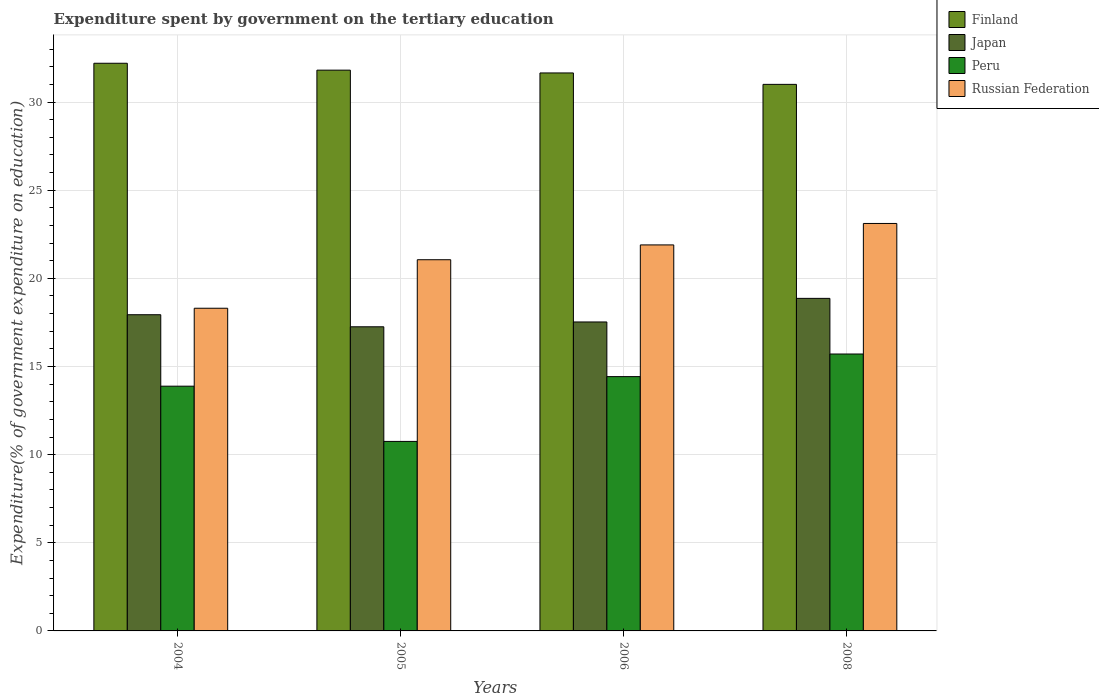Are the number of bars per tick equal to the number of legend labels?
Your answer should be compact. Yes. How many bars are there on the 3rd tick from the left?
Give a very brief answer. 4. What is the label of the 2nd group of bars from the left?
Your answer should be compact. 2005. In how many cases, is the number of bars for a given year not equal to the number of legend labels?
Your response must be concise. 0. What is the expenditure spent by government on the tertiary education in Peru in 2008?
Your answer should be very brief. 15.71. Across all years, what is the maximum expenditure spent by government on the tertiary education in Japan?
Keep it short and to the point. 18.86. Across all years, what is the minimum expenditure spent by government on the tertiary education in Russian Federation?
Your response must be concise. 18.3. In which year was the expenditure spent by government on the tertiary education in Peru maximum?
Keep it short and to the point. 2008. In which year was the expenditure spent by government on the tertiary education in Finland minimum?
Your answer should be compact. 2008. What is the total expenditure spent by government on the tertiary education in Peru in the graph?
Keep it short and to the point. 54.77. What is the difference between the expenditure spent by government on the tertiary education in Finland in 2004 and that in 2008?
Offer a terse response. 1.2. What is the difference between the expenditure spent by government on the tertiary education in Russian Federation in 2008 and the expenditure spent by government on the tertiary education in Peru in 2005?
Ensure brevity in your answer.  12.36. What is the average expenditure spent by government on the tertiary education in Russian Federation per year?
Give a very brief answer. 21.09. In the year 2004, what is the difference between the expenditure spent by government on the tertiary education in Peru and expenditure spent by government on the tertiary education in Japan?
Offer a terse response. -4.05. In how many years, is the expenditure spent by government on the tertiary education in Peru greater than 17 %?
Provide a succinct answer. 0. What is the ratio of the expenditure spent by government on the tertiary education in Finland in 2004 to that in 2005?
Make the answer very short. 1.01. Is the expenditure spent by government on the tertiary education in Russian Federation in 2005 less than that in 2006?
Offer a terse response. Yes. What is the difference between the highest and the second highest expenditure spent by government on the tertiary education in Finland?
Ensure brevity in your answer.  0.39. What is the difference between the highest and the lowest expenditure spent by government on the tertiary education in Russian Federation?
Provide a succinct answer. 4.81. In how many years, is the expenditure spent by government on the tertiary education in Japan greater than the average expenditure spent by government on the tertiary education in Japan taken over all years?
Provide a short and direct response. 2. Is the sum of the expenditure spent by government on the tertiary education in Japan in 2005 and 2008 greater than the maximum expenditure spent by government on the tertiary education in Peru across all years?
Offer a terse response. Yes. What does the 2nd bar from the left in 2005 represents?
Your answer should be compact. Japan. What does the 3rd bar from the right in 2008 represents?
Provide a succinct answer. Japan. How many years are there in the graph?
Your answer should be compact. 4. Does the graph contain any zero values?
Make the answer very short. No. Does the graph contain grids?
Provide a short and direct response. Yes. Where does the legend appear in the graph?
Your answer should be compact. Top right. What is the title of the graph?
Your answer should be compact. Expenditure spent by government on the tertiary education. Does "Bolivia" appear as one of the legend labels in the graph?
Ensure brevity in your answer.  No. What is the label or title of the Y-axis?
Your answer should be compact. Expenditure(% of government expenditure on education). What is the Expenditure(% of government expenditure on education) in Finland in 2004?
Make the answer very short. 32.2. What is the Expenditure(% of government expenditure on education) in Japan in 2004?
Your response must be concise. 17.94. What is the Expenditure(% of government expenditure on education) in Peru in 2004?
Provide a short and direct response. 13.88. What is the Expenditure(% of government expenditure on education) of Russian Federation in 2004?
Keep it short and to the point. 18.3. What is the Expenditure(% of government expenditure on education) in Finland in 2005?
Provide a succinct answer. 31.81. What is the Expenditure(% of government expenditure on education) of Japan in 2005?
Offer a terse response. 17.25. What is the Expenditure(% of government expenditure on education) of Peru in 2005?
Your response must be concise. 10.75. What is the Expenditure(% of government expenditure on education) of Russian Federation in 2005?
Ensure brevity in your answer.  21.06. What is the Expenditure(% of government expenditure on education) in Finland in 2006?
Your response must be concise. 31.65. What is the Expenditure(% of government expenditure on education) of Japan in 2006?
Give a very brief answer. 17.53. What is the Expenditure(% of government expenditure on education) of Peru in 2006?
Keep it short and to the point. 14.43. What is the Expenditure(% of government expenditure on education) in Russian Federation in 2006?
Ensure brevity in your answer.  21.9. What is the Expenditure(% of government expenditure on education) in Finland in 2008?
Offer a very short reply. 31. What is the Expenditure(% of government expenditure on education) in Japan in 2008?
Make the answer very short. 18.86. What is the Expenditure(% of government expenditure on education) in Peru in 2008?
Keep it short and to the point. 15.71. What is the Expenditure(% of government expenditure on education) in Russian Federation in 2008?
Offer a terse response. 23.11. Across all years, what is the maximum Expenditure(% of government expenditure on education) of Finland?
Offer a very short reply. 32.2. Across all years, what is the maximum Expenditure(% of government expenditure on education) of Japan?
Ensure brevity in your answer.  18.86. Across all years, what is the maximum Expenditure(% of government expenditure on education) in Peru?
Ensure brevity in your answer.  15.71. Across all years, what is the maximum Expenditure(% of government expenditure on education) of Russian Federation?
Provide a succinct answer. 23.11. Across all years, what is the minimum Expenditure(% of government expenditure on education) of Finland?
Offer a very short reply. 31. Across all years, what is the minimum Expenditure(% of government expenditure on education) of Japan?
Provide a short and direct response. 17.25. Across all years, what is the minimum Expenditure(% of government expenditure on education) in Peru?
Offer a very short reply. 10.75. Across all years, what is the minimum Expenditure(% of government expenditure on education) of Russian Federation?
Your response must be concise. 18.3. What is the total Expenditure(% of government expenditure on education) of Finland in the graph?
Your response must be concise. 126.67. What is the total Expenditure(% of government expenditure on education) of Japan in the graph?
Your response must be concise. 71.58. What is the total Expenditure(% of government expenditure on education) of Peru in the graph?
Your answer should be compact. 54.77. What is the total Expenditure(% of government expenditure on education) of Russian Federation in the graph?
Your answer should be compact. 84.37. What is the difference between the Expenditure(% of government expenditure on education) in Finland in 2004 and that in 2005?
Make the answer very short. 0.39. What is the difference between the Expenditure(% of government expenditure on education) in Japan in 2004 and that in 2005?
Offer a very short reply. 0.68. What is the difference between the Expenditure(% of government expenditure on education) in Peru in 2004 and that in 2005?
Give a very brief answer. 3.13. What is the difference between the Expenditure(% of government expenditure on education) in Russian Federation in 2004 and that in 2005?
Your answer should be compact. -2.75. What is the difference between the Expenditure(% of government expenditure on education) in Finland in 2004 and that in 2006?
Your answer should be very brief. 0.55. What is the difference between the Expenditure(% of government expenditure on education) in Japan in 2004 and that in 2006?
Your answer should be very brief. 0.41. What is the difference between the Expenditure(% of government expenditure on education) in Peru in 2004 and that in 2006?
Your response must be concise. -0.54. What is the difference between the Expenditure(% of government expenditure on education) in Russian Federation in 2004 and that in 2006?
Make the answer very short. -3.59. What is the difference between the Expenditure(% of government expenditure on education) in Finland in 2004 and that in 2008?
Your answer should be very brief. 1.2. What is the difference between the Expenditure(% of government expenditure on education) of Japan in 2004 and that in 2008?
Ensure brevity in your answer.  -0.93. What is the difference between the Expenditure(% of government expenditure on education) in Peru in 2004 and that in 2008?
Offer a very short reply. -1.82. What is the difference between the Expenditure(% of government expenditure on education) in Russian Federation in 2004 and that in 2008?
Ensure brevity in your answer.  -4.81. What is the difference between the Expenditure(% of government expenditure on education) of Finland in 2005 and that in 2006?
Your answer should be compact. 0.16. What is the difference between the Expenditure(% of government expenditure on education) of Japan in 2005 and that in 2006?
Ensure brevity in your answer.  -0.27. What is the difference between the Expenditure(% of government expenditure on education) of Peru in 2005 and that in 2006?
Provide a short and direct response. -3.68. What is the difference between the Expenditure(% of government expenditure on education) in Russian Federation in 2005 and that in 2006?
Make the answer very short. -0.84. What is the difference between the Expenditure(% of government expenditure on education) of Finland in 2005 and that in 2008?
Provide a short and direct response. 0.81. What is the difference between the Expenditure(% of government expenditure on education) of Japan in 2005 and that in 2008?
Offer a very short reply. -1.61. What is the difference between the Expenditure(% of government expenditure on education) in Peru in 2005 and that in 2008?
Ensure brevity in your answer.  -4.96. What is the difference between the Expenditure(% of government expenditure on education) in Russian Federation in 2005 and that in 2008?
Your answer should be very brief. -2.06. What is the difference between the Expenditure(% of government expenditure on education) in Finland in 2006 and that in 2008?
Give a very brief answer. 0.65. What is the difference between the Expenditure(% of government expenditure on education) of Japan in 2006 and that in 2008?
Provide a succinct answer. -1.34. What is the difference between the Expenditure(% of government expenditure on education) in Peru in 2006 and that in 2008?
Keep it short and to the point. -1.28. What is the difference between the Expenditure(% of government expenditure on education) in Russian Federation in 2006 and that in 2008?
Ensure brevity in your answer.  -1.22. What is the difference between the Expenditure(% of government expenditure on education) of Finland in 2004 and the Expenditure(% of government expenditure on education) of Japan in 2005?
Ensure brevity in your answer.  14.95. What is the difference between the Expenditure(% of government expenditure on education) in Finland in 2004 and the Expenditure(% of government expenditure on education) in Peru in 2005?
Provide a short and direct response. 21.45. What is the difference between the Expenditure(% of government expenditure on education) of Finland in 2004 and the Expenditure(% of government expenditure on education) of Russian Federation in 2005?
Your response must be concise. 11.14. What is the difference between the Expenditure(% of government expenditure on education) of Japan in 2004 and the Expenditure(% of government expenditure on education) of Peru in 2005?
Make the answer very short. 7.19. What is the difference between the Expenditure(% of government expenditure on education) in Japan in 2004 and the Expenditure(% of government expenditure on education) in Russian Federation in 2005?
Provide a short and direct response. -3.12. What is the difference between the Expenditure(% of government expenditure on education) in Peru in 2004 and the Expenditure(% of government expenditure on education) in Russian Federation in 2005?
Your answer should be very brief. -7.17. What is the difference between the Expenditure(% of government expenditure on education) of Finland in 2004 and the Expenditure(% of government expenditure on education) of Japan in 2006?
Ensure brevity in your answer.  14.68. What is the difference between the Expenditure(% of government expenditure on education) of Finland in 2004 and the Expenditure(% of government expenditure on education) of Peru in 2006?
Offer a very short reply. 17.78. What is the difference between the Expenditure(% of government expenditure on education) in Finland in 2004 and the Expenditure(% of government expenditure on education) in Russian Federation in 2006?
Your response must be concise. 10.3. What is the difference between the Expenditure(% of government expenditure on education) of Japan in 2004 and the Expenditure(% of government expenditure on education) of Peru in 2006?
Provide a succinct answer. 3.51. What is the difference between the Expenditure(% of government expenditure on education) of Japan in 2004 and the Expenditure(% of government expenditure on education) of Russian Federation in 2006?
Your answer should be very brief. -3.96. What is the difference between the Expenditure(% of government expenditure on education) of Peru in 2004 and the Expenditure(% of government expenditure on education) of Russian Federation in 2006?
Your response must be concise. -8.01. What is the difference between the Expenditure(% of government expenditure on education) of Finland in 2004 and the Expenditure(% of government expenditure on education) of Japan in 2008?
Provide a succinct answer. 13.34. What is the difference between the Expenditure(% of government expenditure on education) of Finland in 2004 and the Expenditure(% of government expenditure on education) of Peru in 2008?
Your answer should be very brief. 16.49. What is the difference between the Expenditure(% of government expenditure on education) of Finland in 2004 and the Expenditure(% of government expenditure on education) of Russian Federation in 2008?
Keep it short and to the point. 9.09. What is the difference between the Expenditure(% of government expenditure on education) in Japan in 2004 and the Expenditure(% of government expenditure on education) in Peru in 2008?
Provide a short and direct response. 2.23. What is the difference between the Expenditure(% of government expenditure on education) in Japan in 2004 and the Expenditure(% of government expenditure on education) in Russian Federation in 2008?
Your answer should be very brief. -5.18. What is the difference between the Expenditure(% of government expenditure on education) of Peru in 2004 and the Expenditure(% of government expenditure on education) of Russian Federation in 2008?
Give a very brief answer. -9.23. What is the difference between the Expenditure(% of government expenditure on education) in Finland in 2005 and the Expenditure(% of government expenditure on education) in Japan in 2006?
Offer a very short reply. 14.28. What is the difference between the Expenditure(% of government expenditure on education) in Finland in 2005 and the Expenditure(% of government expenditure on education) in Peru in 2006?
Your response must be concise. 17.38. What is the difference between the Expenditure(% of government expenditure on education) of Finland in 2005 and the Expenditure(% of government expenditure on education) of Russian Federation in 2006?
Keep it short and to the point. 9.91. What is the difference between the Expenditure(% of government expenditure on education) of Japan in 2005 and the Expenditure(% of government expenditure on education) of Peru in 2006?
Provide a succinct answer. 2.83. What is the difference between the Expenditure(% of government expenditure on education) of Japan in 2005 and the Expenditure(% of government expenditure on education) of Russian Federation in 2006?
Provide a succinct answer. -4.64. What is the difference between the Expenditure(% of government expenditure on education) in Peru in 2005 and the Expenditure(% of government expenditure on education) in Russian Federation in 2006?
Your answer should be very brief. -11.15. What is the difference between the Expenditure(% of government expenditure on education) of Finland in 2005 and the Expenditure(% of government expenditure on education) of Japan in 2008?
Keep it short and to the point. 12.95. What is the difference between the Expenditure(% of government expenditure on education) of Finland in 2005 and the Expenditure(% of government expenditure on education) of Peru in 2008?
Provide a short and direct response. 16.1. What is the difference between the Expenditure(% of government expenditure on education) of Finland in 2005 and the Expenditure(% of government expenditure on education) of Russian Federation in 2008?
Offer a terse response. 8.7. What is the difference between the Expenditure(% of government expenditure on education) of Japan in 2005 and the Expenditure(% of government expenditure on education) of Peru in 2008?
Keep it short and to the point. 1.54. What is the difference between the Expenditure(% of government expenditure on education) in Japan in 2005 and the Expenditure(% of government expenditure on education) in Russian Federation in 2008?
Your response must be concise. -5.86. What is the difference between the Expenditure(% of government expenditure on education) of Peru in 2005 and the Expenditure(% of government expenditure on education) of Russian Federation in 2008?
Provide a short and direct response. -12.36. What is the difference between the Expenditure(% of government expenditure on education) in Finland in 2006 and the Expenditure(% of government expenditure on education) in Japan in 2008?
Provide a short and direct response. 12.79. What is the difference between the Expenditure(% of government expenditure on education) in Finland in 2006 and the Expenditure(% of government expenditure on education) in Peru in 2008?
Your answer should be very brief. 15.94. What is the difference between the Expenditure(% of government expenditure on education) of Finland in 2006 and the Expenditure(% of government expenditure on education) of Russian Federation in 2008?
Keep it short and to the point. 8.54. What is the difference between the Expenditure(% of government expenditure on education) in Japan in 2006 and the Expenditure(% of government expenditure on education) in Peru in 2008?
Offer a very short reply. 1.82. What is the difference between the Expenditure(% of government expenditure on education) in Japan in 2006 and the Expenditure(% of government expenditure on education) in Russian Federation in 2008?
Your answer should be compact. -5.59. What is the difference between the Expenditure(% of government expenditure on education) of Peru in 2006 and the Expenditure(% of government expenditure on education) of Russian Federation in 2008?
Offer a terse response. -8.69. What is the average Expenditure(% of government expenditure on education) of Finland per year?
Provide a short and direct response. 31.67. What is the average Expenditure(% of government expenditure on education) of Japan per year?
Keep it short and to the point. 17.89. What is the average Expenditure(% of government expenditure on education) of Peru per year?
Provide a succinct answer. 13.69. What is the average Expenditure(% of government expenditure on education) in Russian Federation per year?
Provide a succinct answer. 21.09. In the year 2004, what is the difference between the Expenditure(% of government expenditure on education) in Finland and Expenditure(% of government expenditure on education) in Japan?
Your response must be concise. 14.26. In the year 2004, what is the difference between the Expenditure(% of government expenditure on education) in Finland and Expenditure(% of government expenditure on education) in Peru?
Ensure brevity in your answer.  18.32. In the year 2004, what is the difference between the Expenditure(% of government expenditure on education) of Finland and Expenditure(% of government expenditure on education) of Russian Federation?
Your answer should be very brief. 13.9. In the year 2004, what is the difference between the Expenditure(% of government expenditure on education) of Japan and Expenditure(% of government expenditure on education) of Peru?
Ensure brevity in your answer.  4.05. In the year 2004, what is the difference between the Expenditure(% of government expenditure on education) of Japan and Expenditure(% of government expenditure on education) of Russian Federation?
Ensure brevity in your answer.  -0.37. In the year 2004, what is the difference between the Expenditure(% of government expenditure on education) in Peru and Expenditure(% of government expenditure on education) in Russian Federation?
Your answer should be compact. -4.42. In the year 2005, what is the difference between the Expenditure(% of government expenditure on education) of Finland and Expenditure(% of government expenditure on education) of Japan?
Your response must be concise. 14.56. In the year 2005, what is the difference between the Expenditure(% of government expenditure on education) of Finland and Expenditure(% of government expenditure on education) of Peru?
Offer a terse response. 21.06. In the year 2005, what is the difference between the Expenditure(% of government expenditure on education) of Finland and Expenditure(% of government expenditure on education) of Russian Federation?
Give a very brief answer. 10.75. In the year 2005, what is the difference between the Expenditure(% of government expenditure on education) of Japan and Expenditure(% of government expenditure on education) of Peru?
Provide a succinct answer. 6.5. In the year 2005, what is the difference between the Expenditure(% of government expenditure on education) of Japan and Expenditure(% of government expenditure on education) of Russian Federation?
Your response must be concise. -3.8. In the year 2005, what is the difference between the Expenditure(% of government expenditure on education) in Peru and Expenditure(% of government expenditure on education) in Russian Federation?
Provide a succinct answer. -10.31. In the year 2006, what is the difference between the Expenditure(% of government expenditure on education) of Finland and Expenditure(% of government expenditure on education) of Japan?
Provide a short and direct response. 14.13. In the year 2006, what is the difference between the Expenditure(% of government expenditure on education) in Finland and Expenditure(% of government expenditure on education) in Peru?
Provide a short and direct response. 17.23. In the year 2006, what is the difference between the Expenditure(% of government expenditure on education) of Finland and Expenditure(% of government expenditure on education) of Russian Federation?
Ensure brevity in your answer.  9.76. In the year 2006, what is the difference between the Expenditure(% of government expenditure on education) of Japan and Expenditure(% of government expenditure on education) of Peru?
Your answer should be compact. 3.1. In the year 2006, what is the difference between the Expenditure(% of government expenditure on education) in Japan and Expenditure(% of government expenditure on education) in Russian Federation?
Make the answer very short. -4.37. In the year 2006, what is the difference between the Expenditure(% of government expenditure on education) of Peru and Expenditure(% of government expenditure on education) of Russian Federation?
Provide a succinct answer. -7.47. In the year 2008, what is the difference between the Expenditure(% of government expenditure on education) of Finland and Expenditure(% of government expenditure on education) of Japan?
Your answer should be very brief. 12.14. In the year 2008, what is the difference between the Expenditure(% of government expenditure on education) of Finland and Expenditure(% of government expenditure on education) of Peru?
Offer a terse response. 15.3. In the year 2008, what is the difference between the Expenditure(% of government expenditure on education) of Finland and Expenditure(% of government expenditure on education) of Russian Federation?
Your response must be concise. 7.89. In the year 2008, what is the difference between the Expenditure(% of government expenditure on education) of Japan and Expenditure(% of government expenditure on education) of Peru?
Give a very brief answer. 3.16. In the year 2008, what is the difference between the Expenditure(% of government expenditure on education) in Japan and Expenditure(% of government expenditure on education) in Russian Federation?
Offer a very short reply. -4.25. In the year 2008, what is the difference between the Expenditure(% of government expenditure on education) in Peru and Expenditure(% of government expenditure on education) in Russian Federation?
Your answer should be compact. -7.41. What is the ratio of the Expenditure(% of government expenditure on education) in Finland in 2004 to that in 2005?
Provide a succinct answer. 1.01. What is the ratio of the Expenditure(% of government expenditure on education) in Japan in 2004 to that in 2005?
Offer a terse response. 1.04. What is the ratio of the Expenditure(% of government expenditure on education) of Peru in 2004 to that in 2005?
Your answer should be very brief. 1.29. What is the ratio of the Expenditure(% of government expenditure on education) of Russian Federation in 2004 to that in 2005?
Make the answer very short. 0.87. What is the ratio of the Expenditure(% of government expenditure on education) in Finland in 2004 to that in 2006?
Ensure brevity in your answer.  1.02. What is the ratio of the Expenditure(% of government expenditure on education) of Japan in 2004 to that in 2006?
Provide a succinct answer. 1.02. What is the ratio of the Expenditure(% of government expenditure on education) in Peru in 2004 to that in 2006?
Ensure brevity in your answer.  0.96. What is the ratio of the Expenditure(% of government expenditure on education) in Russian Federation in 2004 to that in 2006?
Your answer should be very brief. 0.84. What is the ratio of the Expenditure(% of government expenditure on education) of Finland in 2004 to that in 2008?
Give a very brief answer. 1.04. What is the ratio of the Expenditure(% of government expenditure on education) in Japan in 2004 to that in 2008?
Your response must be concise. 0.95. What is the ratio of the Expenditure(% of government expenditure on education) of Peru in 2004 to that in 2008?
Ensure brevity in your answer.  0.88. What is the ratio of the Expenditure(% of government expenditure on education) in Russian Federation in 2004 to that in 2008?
Provide a succinct answer. 0.79. What is the ratio of the Expenditure(% of government expenditure on education) of Japan in 2005 to that in 2006?
Make the answer very short. 0.98. What is the ratio of the Expenditure(% of government expenditure on education) in Peru in 2005 to that in 2006?
Make the answer very short. 0.75. What is the ratio of the Expenditure(% of government expenditure on education) in Russian Federation in 2005 to that in 2006?
Give a very brief answer. 0.96. What is the ratio of the Expenditure(% of government expenditure on education) in Finland in 2005 to that in 2008?
Offer a terse response. 1.03. What is the ratio of the Expenditure(% of government expenditure on education) in Japan in 2005 to that in 2008?
Keep it short and to the point. 0.91. What is the ratio of the Expenditure(% of government expenditure on education) of Peru in 2005 to that in 2008?
Your answer should be very brief. 0.68. What is the ratio of the Expenditure(% of government expenditure on education) in Russian Federation in 2005 to that in 2008?
Give a very brief answer. 0.91. What is the ratio of the Expenditure(% of government expenditure on education) of Finland in 2006 to that in 2008?
Provide a short and direct response. 1.02. What is the ratio of the Expenditure(% of government expenditure on education) of Japan in 2006 to that in 2008?
Keep it short and to the point. 0.93. What is the ratio of the Expenditure(% of government expenditure on education) of Peru in 2006 to that in 2008?
Your response must be concise. 0.92. What is the ratio of the Expenditure(% of government expenditure on education) of Russian Federation in 2006 to that in 2008?
Ensure brevity in your answer.  0.95. What is the difference between the highest and the second highest Expenditure(% of government expenditure on education) in Finland?
Offer a terse response. 0.39. What is the difference between the highest and the second highest Expenditure(% of government expenditure on education) in Japan?
Keep it short and to the point. 0.93. What is the difference between the highest and the second highest Expenditure(% of government expenditure on education) in Peru?
Keep it short and to the point. 1.28. What is the difference between the highest and the second highest Expenditure(% of government expenditure on education) in Russian Federation?
Your answer should be very brief. 1.22. What is the difference between the highest and the lowest Expenditure(% of government expenditure on education) of Finland?
Offer a terse response. 1.2. What is the difference between the highest and the lowest Expenditure(% of government expenditure on education) of Japan?
Keep it short and to the point. 1.61. What is the difference between the highest and the lowest Expenditure(% of government expenditure on education) in Peru?
Make the answer very short. 4.96. What is the difference between the highest and the lowest Expenditure(% of government expenditure on education) of Russian Federation?
Provide a succinct answer. 4.81. 